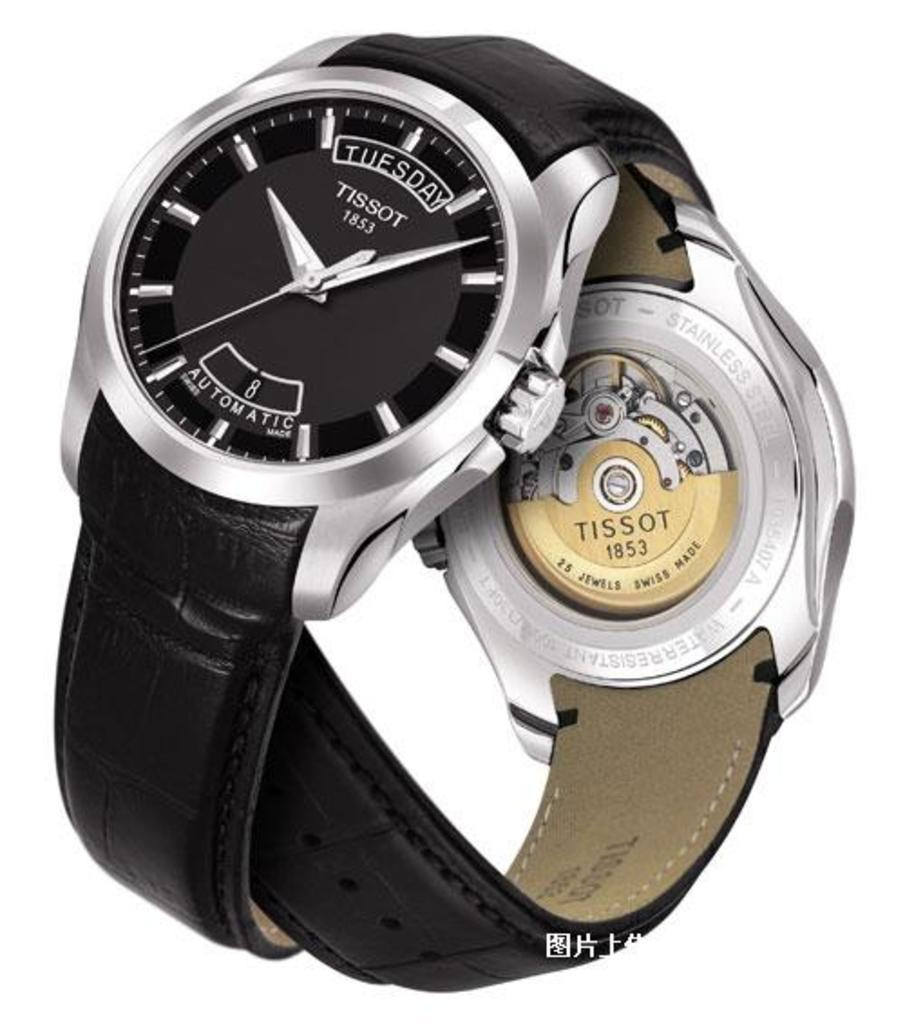<image>
Provide a brief description of the given image. Two gorgeous blackTissot watches intertwined with each other. 